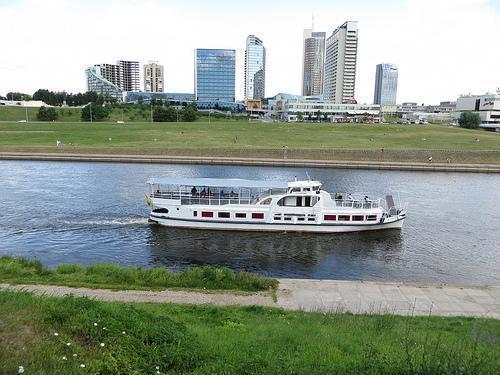How many skyscrapers are there?
Give a very brief answer. 7. 